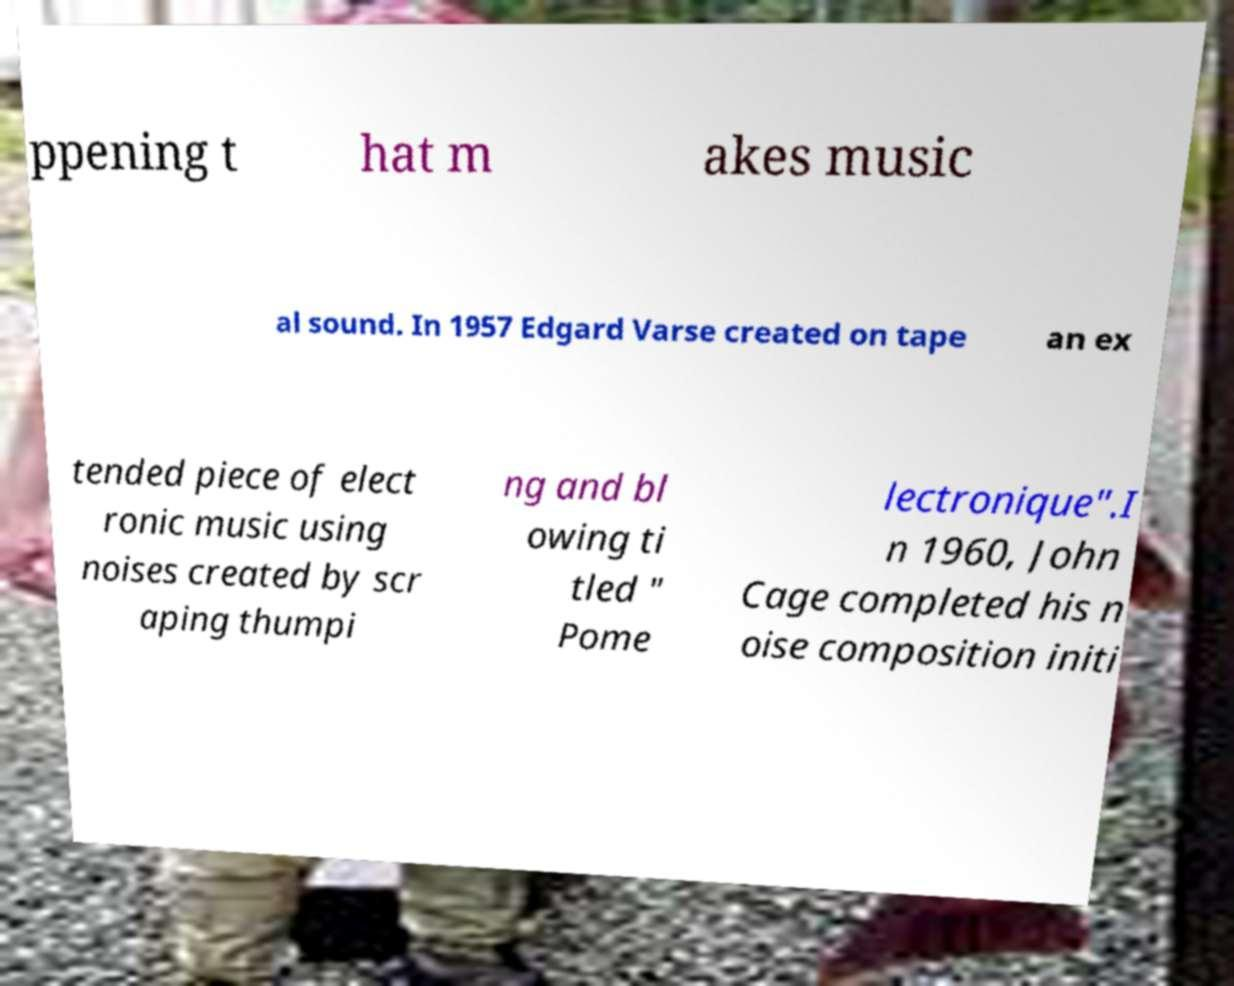Can you accurately transcribe the text from the provided image for me? ppening t hat m akes music al sound. In 1957 Edgard Varse created on tape an ex tended piece of elect ronic music using noises created by scr aping thumpi ng and bl owing ti tled " Pome lectronique".I n 1960, John Cage completed his n oise composition initi 